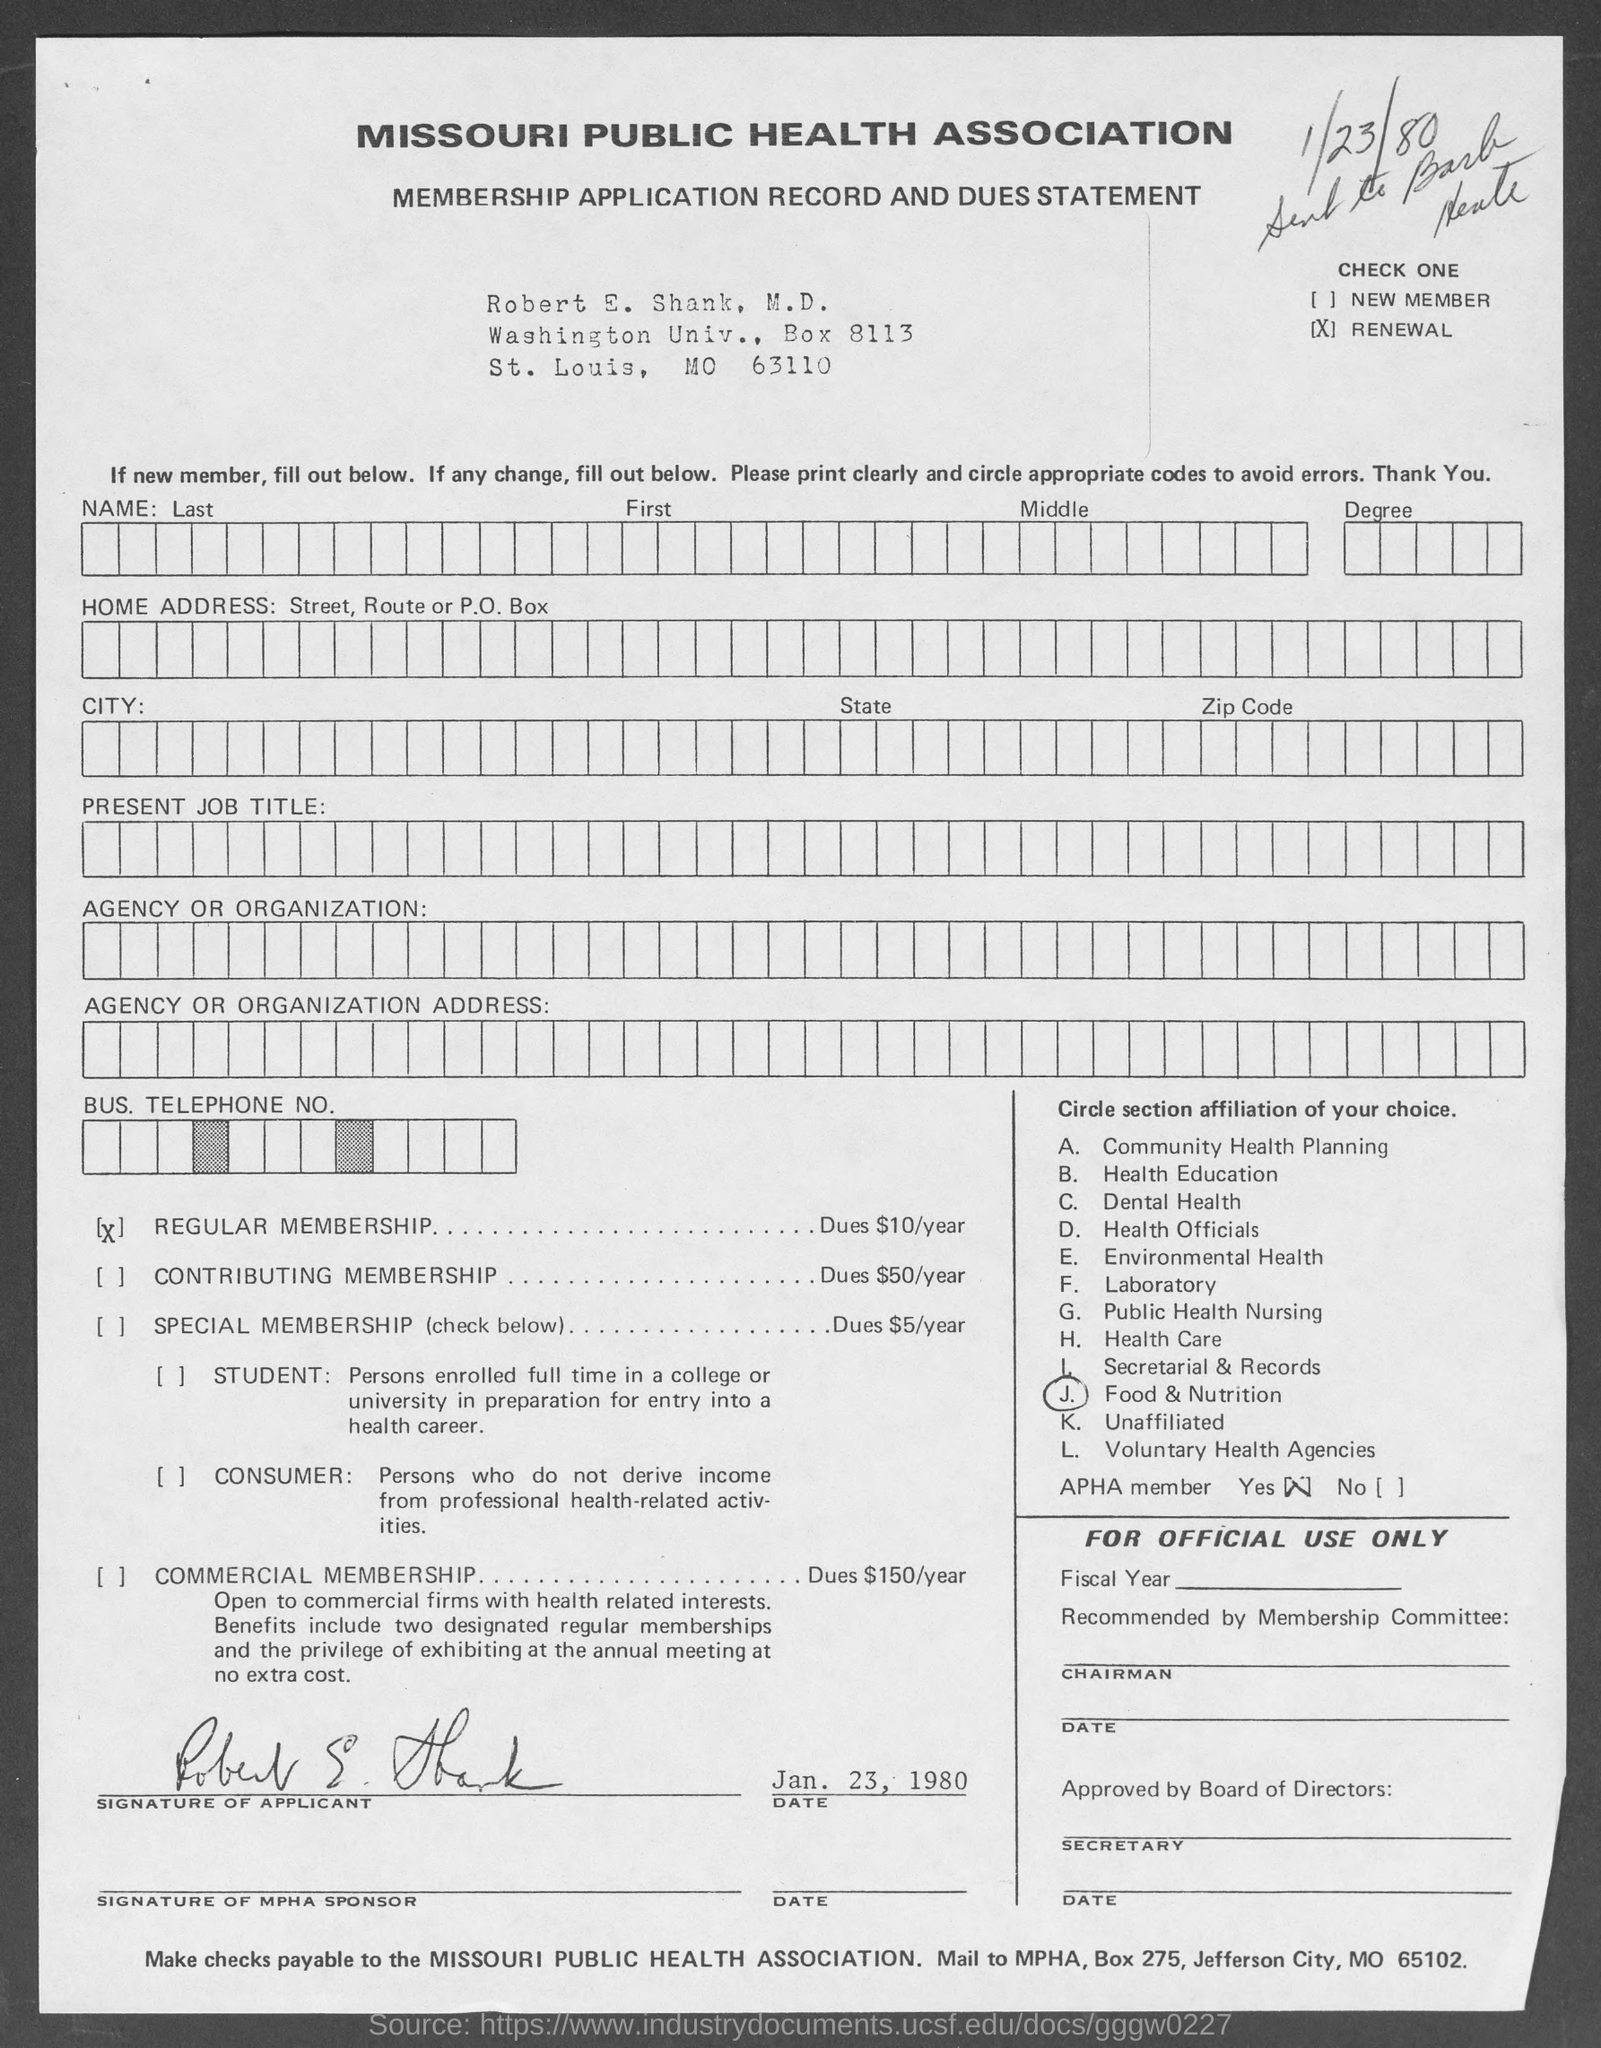Highlight a few significant elements in this photo. The organization is called the Missouri Public Health Association. 